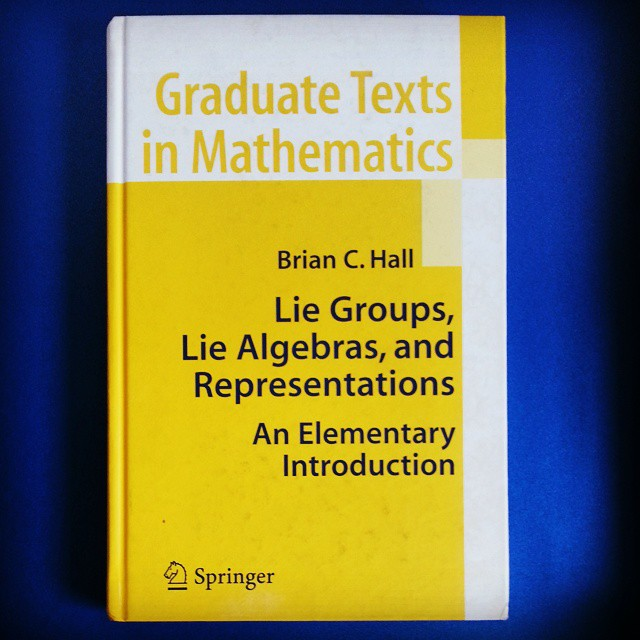How might representations be useful in a practical context? In practical terms, representations let us use matrices to study complex structures. For instance, they allow physicists to use linear algebra to solve problems in quantum mechanics, where particles' states and transformations are described mathematically. By converting abstract algebraic objects into manageable matrices, representations make it possible to perform concrete calculations that predict physical behaviors and outcomes. 